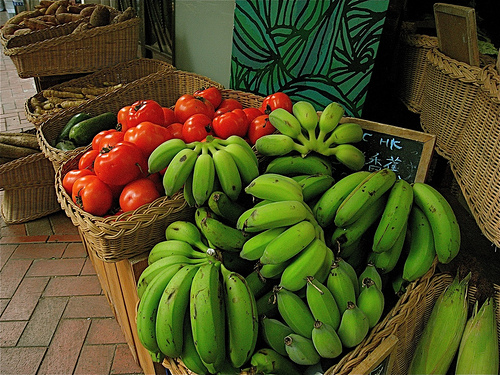Identify and read out the text in this image. HK 